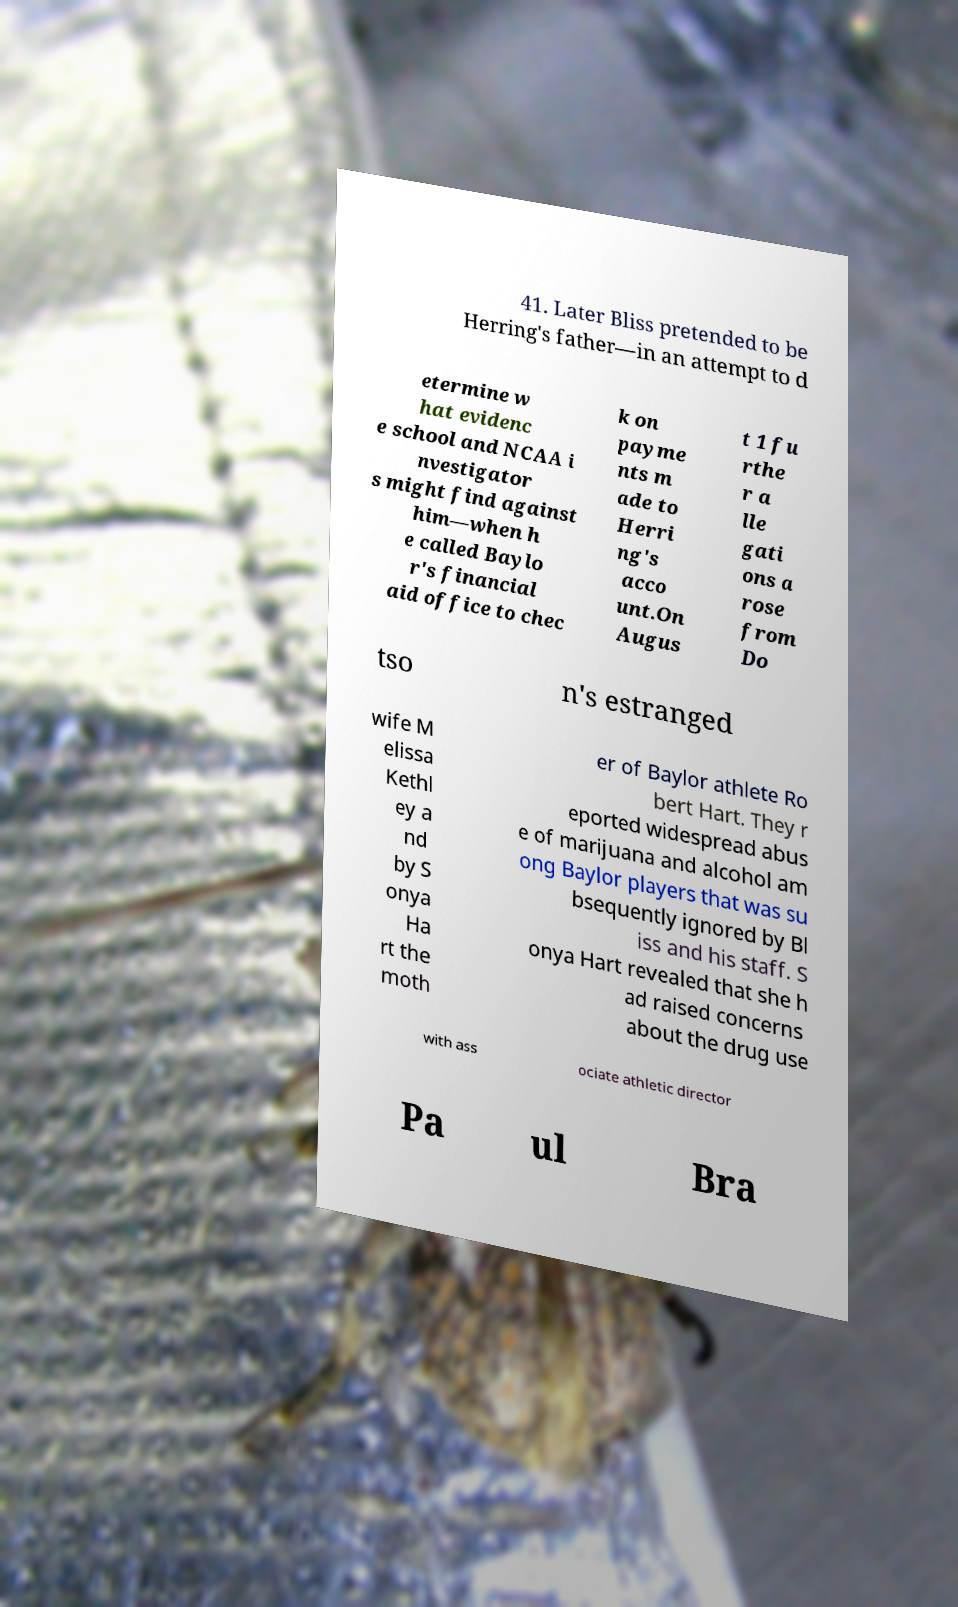Could you extract and type out the text from this image? 41. Later Bliss pretended to be Herring's father—in an attempt to d etermine w hat evidenc e school and NCAA i nvestigator s might find against him—when h e called Baylo r's financial aid office to chec k on payme nts m ade to Herri ng's acco unt.On Augus t 1 fu rthe r a lle gati ons a rose from Do tso n's estranged wife M elissa Kethl ey a nd by S onya Ha rt the moth er of Baylor athlete Ro bert Hart. They r eported widespread abus e of marijuana and alcohol am ong Baylor players that was su bsequently ignored by Bl iss and his staff. S onya Hart revealed that she h ad raised concerns about the drug use with ass ociate athletic director Pa ul Bra 